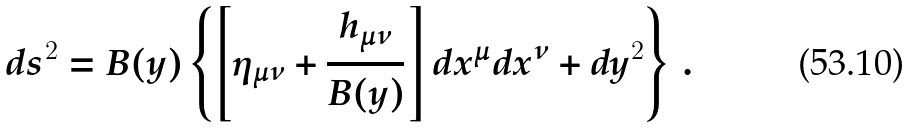<formula> <loc_0><loc_0><loc_500><loc_500>d s ^ { 2 } = B ( y ) \left \{ \left [ \eta _ { \mu \nu } + { \frac { h _ { \mu \nu } } { B ( y ) } } \right ] d x ^ { \mu } d x ^ { \nu } + d y ^ { 2 } \right \} \, .</formula> 